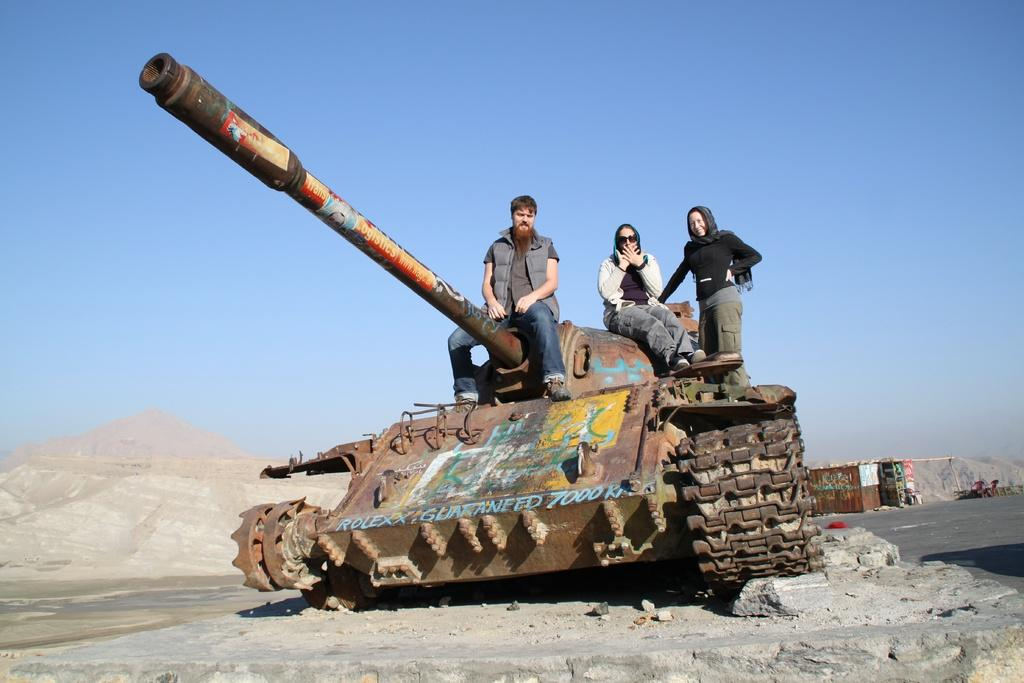What is the main subject of the image? The main subject of the image is a war tank on the ground. Are there any people present in the image? Yes, there are three persons sitting on the war tank. What type of terrain can be seen in the image? There are rocks visible in the image, and there are mountains in the background. What is visible in the sky? The sky is visible in the image. What type of drawer can be seen in the image? There is no drawer present in the image. Can you tell me how many firemen are visible in the image? There are no firemen present in the image; it features a war tank with three persons sitting on it. 